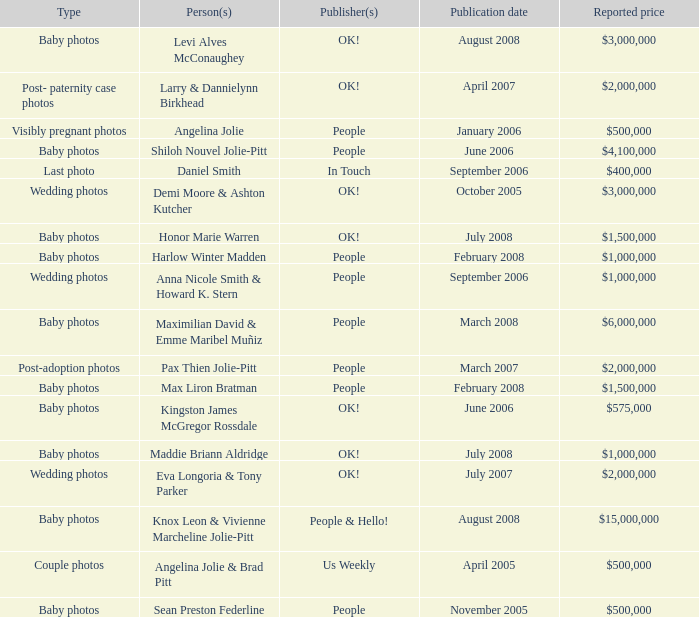What type of photos of Angelina Jolie cost $500,000? Visibly pregnant photos. 